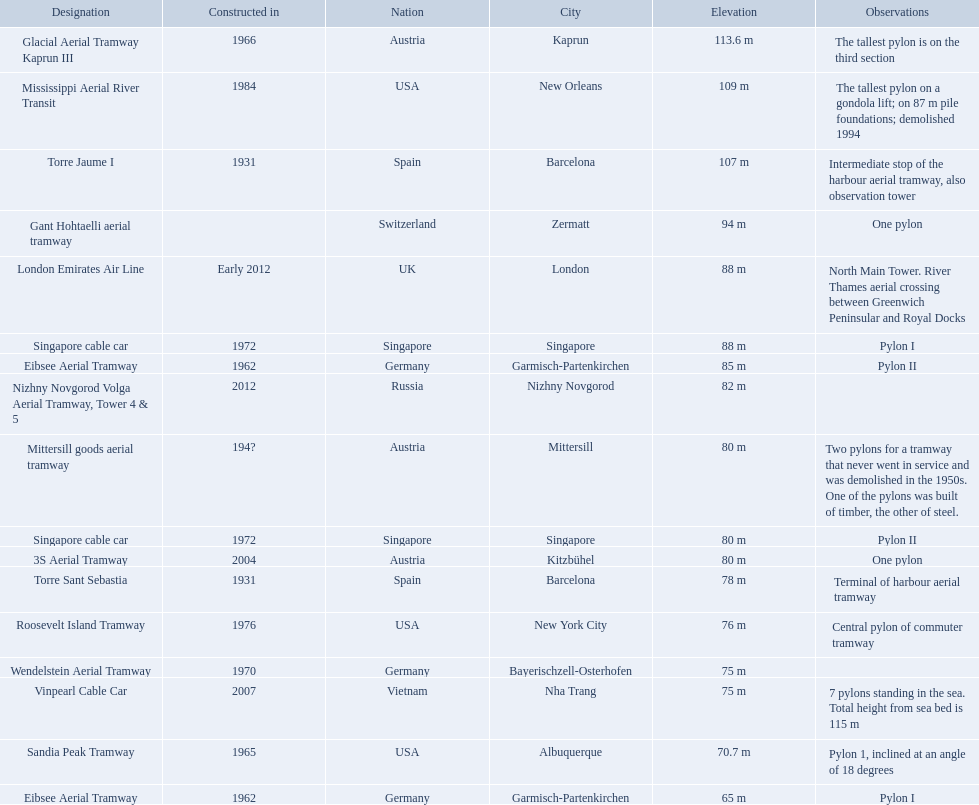How many aerial lift pylon's on the list are located in the usa? Mississippi Aerial River Transit, Roosevelt Island Tramway, Sandia Peak Tramway. Of the pylon's located in the usa how many were built after 1970? Mississippi Aerial River Transit, Roosevelt Island Tramway. Of the pylon's built after 1970 which is the tallest pylon on a gondola lift? Mississippi Aerial River Transit. How many meters is the tallest pylon on a gondola lift? 109 m. 